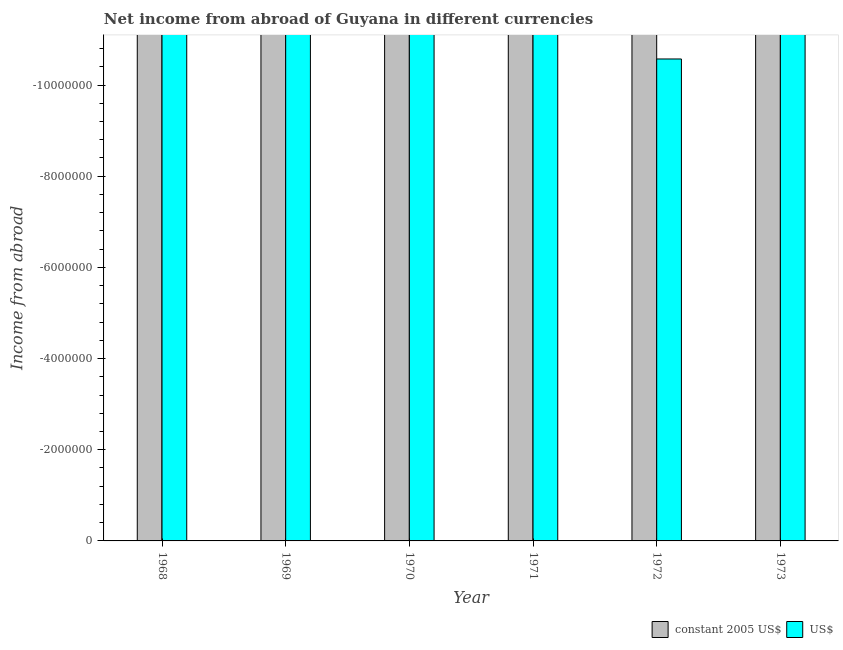How many bars are there on the 5th tick from the right?
Keep it short and to the point. 0. What is the label of the 5th group of bars from the left?
Provide a short and direct response. 1972. In how many cases, is the number of bars for a given year not equal to the number of legend labels?
Provide a succinct answer. 6. What is the income from abroad in us$ in 1968?
Provide a short and direct response. 0. Across all years, what is the minimum income from abroad in constant 2005 us$?
Ensure brevity in your answer.  0. What is the total income from abroad in us$ in the graph?
Your answer should be very brief. 0. In how many years, is the income from abroad in us$ greater than -1600000 units?
Provide a succinct answer. 0. How many bars are there?
Give a very brief answer. 0. Are all the bars in the graph horizontal?
Offer a very short reply. No. How many years are there in the graph?
Your answer should be very brief. 6. Are the values on the major ticks of Y-axis written in scientific E-notation?
Provide a short and direct response. No. Does the graph contain any zero values?
Keep it short and to the point. Yes. Does the graph contain grids?
Offer a very short reply. No. Where does the legend appear in the graph?
Ensure brevity in your answer.  Bottom right. What is the title of the graph?
Provide a succinct answer. Net income from abroad of Guyana in different currencies. What is the label or title of the X-axis?
Your answer should be compact. Year. What is the label or title of the Y-axis?
Keep it short and to the point. Income from abroad. What is the Income from abroad of constant 2005 US$ in 1970?
Keep it short and to the point. 0. What is the Income from abroad in US$ in 1970?
Your answer should be very brief. 0. What is the Income from abroad in US$ in 1973?
Make the answer very short. 0. What is the total Income from abroad in constant 2005 US$ in the graph?
Offer a terse response. 0. What is the average Income from abroad of US$ per year?
Offer a terse response. 0. 